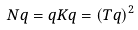<formula> <loc_0><loc_0><loc_500><loc_500>N q = q K q = ( T q ) ^ { 2 }</formula> 